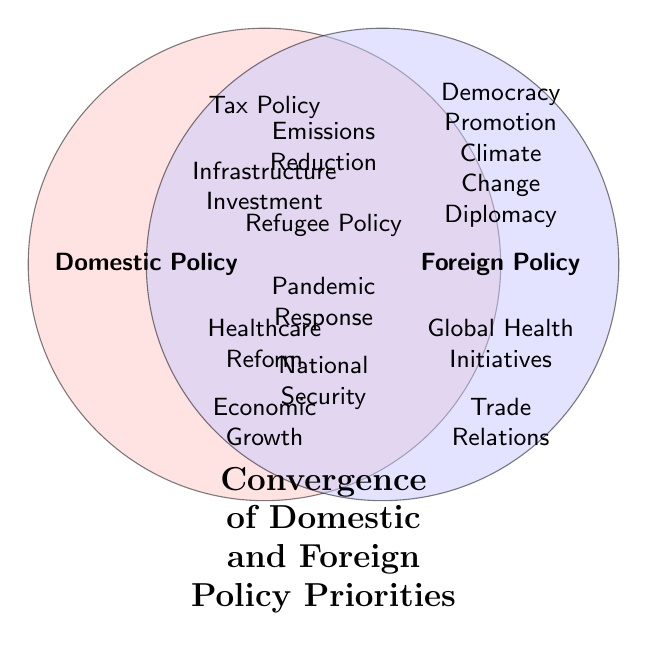What's the title of the figure? The figure has a single title at the bottom.
Answer: Convergence of Domestic and Foreign Policy Priorities Which policy areas overlap between domestic and foreign policy in the middle of the Venn diagram? The middle area lists the items that fall under both domestic and foreign policy areas.
Answer: National Security, Pandemic Response, Refugee Policy, Emissions Reduction How many domestic policy priorities are shown in the figure? The domestic policy priorities are listed on the left side of the Venn diagram. Count them.
Answer: 4 Which has more policy items listed: Domestic Policy or Foreign Policy? Compare the number of items listed on the domestic and foreign policy sides of the Venn diagram.
Answer: Foreign Policy What is the common policy area between climate change diplomacy and environmental regulations? Locate climate change diplomacy in the foreign policy circle and environmental regulations in the domestic policy circle. Check the Venn diagram's intersection.
Answer: Emissions Reduction Identify a policy area that is part of the domestic policy but not the foreign policy. Look at the left part of the Venn diagram inside the circle representing Domestic Policy but outside the intersection area.
Answer: Economic Growth, Healthcare Reform, Infrastructure Investment, or Tax Policy What issue connects healthcare reform and global health initiatives? Locate healthcare reform on the domestic policy side and global health initiatives on the foreign policy side. Check the overlapping section.
Answer: Pandemic Response Which policy area stands between trade relations and economic growth in the Venn diagram? Locate trade relations on the foreign policy side and economic growth on the domestic policy side. Check the intersection section.
Answer: Economic Sanctions How is the concept of election integrity connected to democracy promotion in the Venn diagram? Identify election integrity within the domestic policy circle and democracy promotion within the foreign policy circle. Look at their intersection.
Answer: Electoral Assistance What is the relationship between immigration reform and border security as depicted in the Venn diagram? Locate immigration reform in the domestic policy section and border security in the foreign policy section. Then check their overlap in the Venn diagram.
Answer: Refugee Policy 